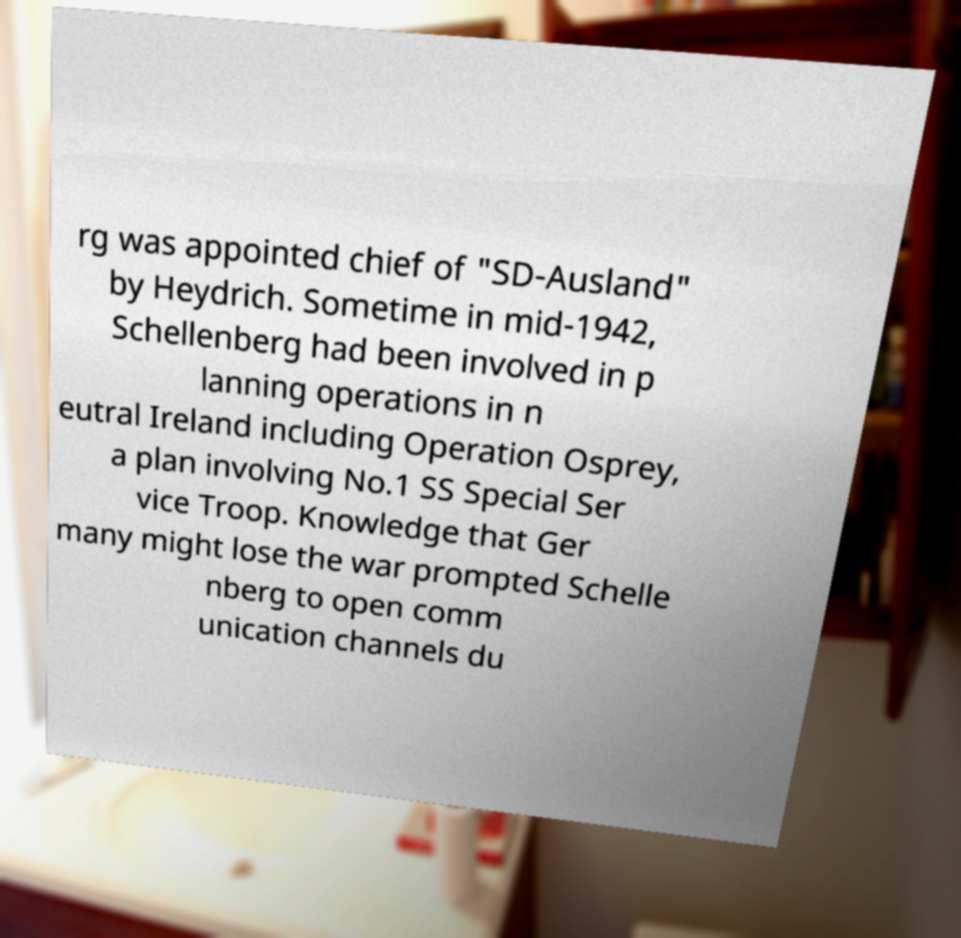Please read and relay the text visible in this image. What does it say? rg was appointed chief of "SD-Ausland" by Heydrich. Sometime in mid-1942, Schellenberg had been involved in p lanning operations in n eutral Ireland including Operation Osprey, a plan involving No.1 SS Special Ser vice Troop. Knowledge that Ger many might lose the war prompted Schelle nberg to open comm unication channels du 